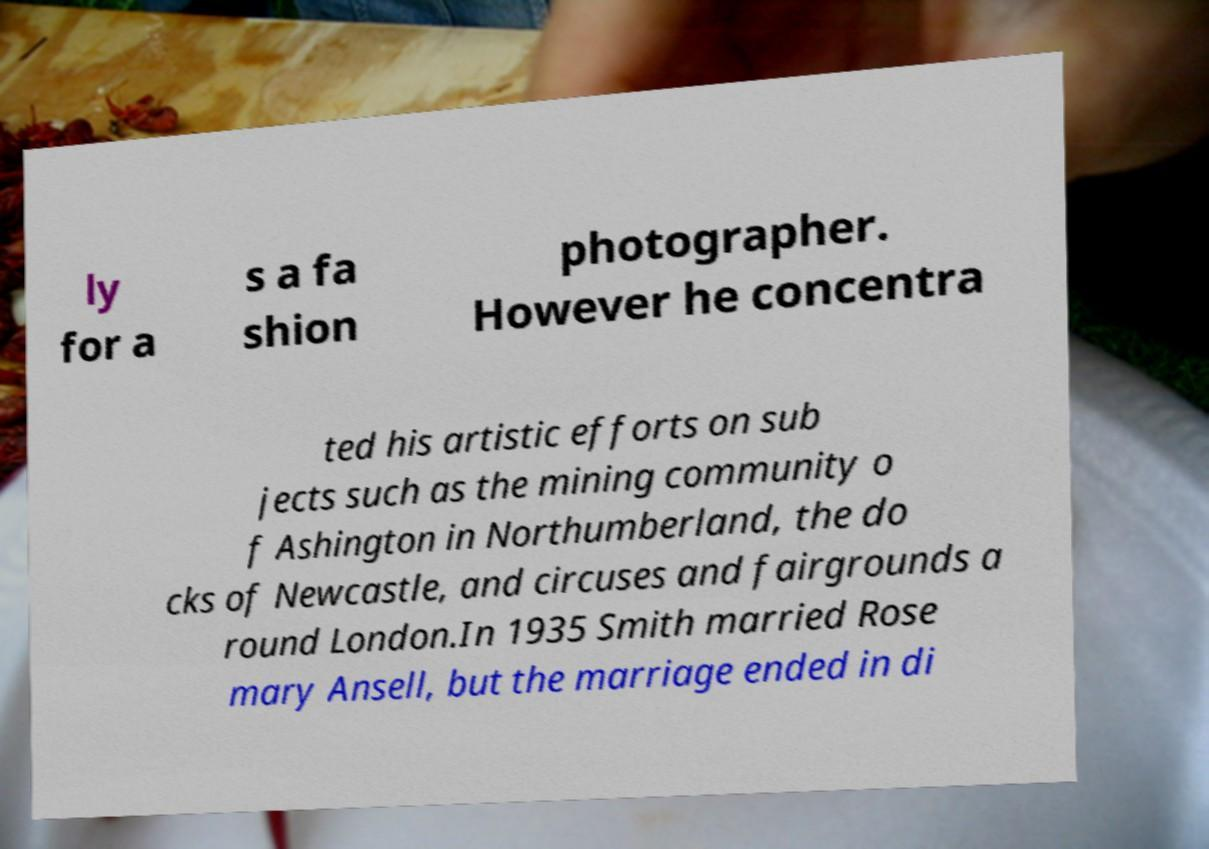Please read and relay the text visible in this image. What does it say? ly for a s a fa shion photographer. However he concentra ted his artistic efforts on sub jects such as the mining community o f Ashington in Northumberland, the do cks of Newcastle, and circuses and fairgrounds a round London.In 1935 Smith married Rose mary Ansell, but the marriage ended in di 